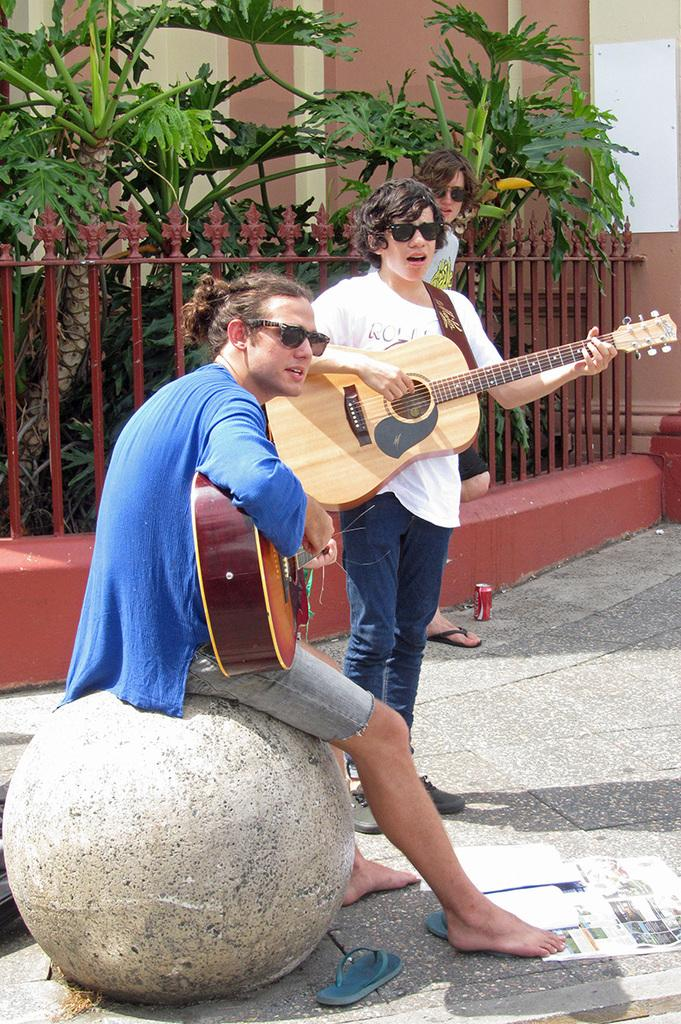How many people are in the image? There are three persons in the image. What are two of the persons holding? Two of the persons are holding guitars. What is the position of the third person? One person is sitting on a stone. What can be seen in the background of the image? There is a fence and plants in the background of the image. What type of cloth is draped over the mountain in the image? There is no mountain or cloth present in the image. How many coils are visible on the fence in the image? There is no mention of coils on the fence in the image; it only states that there is a fence in the background. 